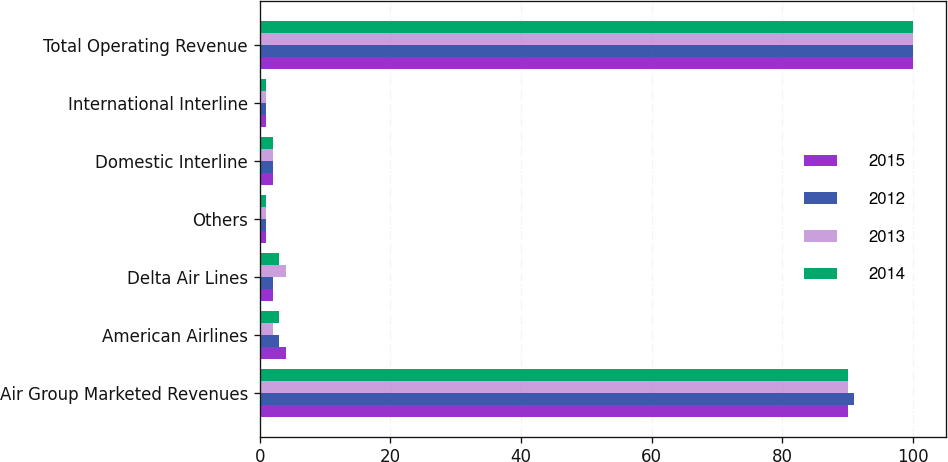Convert chart to OTSL. <chart><loc_0><loc_0><loc_500><loc_500><stacked_bar_chart><ecel><fcel>Air Group Marketed Revenues<fcel>American Airlines<fcel>Delta Air Lines<fcel>Others<fcel>Domestic Interline<fcel>International Interline<fcel>Total Operating Revenue<nl><fcel>2015<fcel>90<fcel>4<fcel>2<fcel>1<fcel>2<fcel>1<fcel>100<nl><fcel>2012<fcel>91<fcel>3<fcel>2<fcel>1<fcel>2<fcel>1<fcel>100<nl><fcel>2013<fcel>90<fcel>2<fcel>4<fcel>1<fcel>2<fcel>1<fcel>100<nl><fcel>2014<fcel>90<fcel>3<fcel>3<fcel>1<fcel>2<fcel>1<fcel>100<nl></chart> 